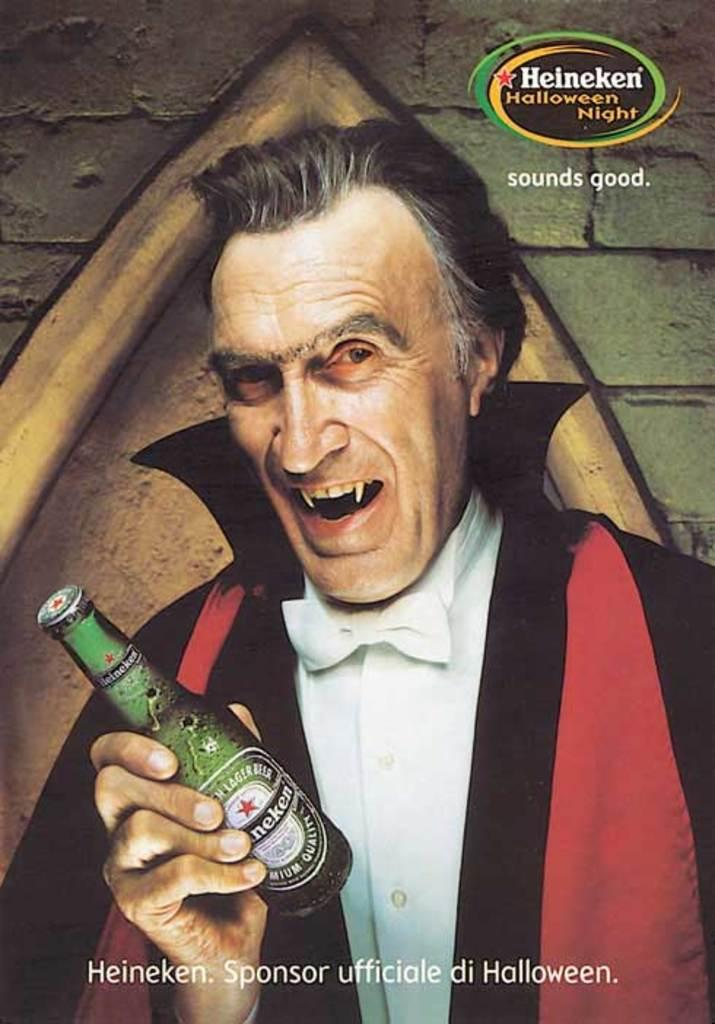Who is present in the image? There is a man in the image. What is the man holding in his hand? The man is holding a bottle in his hand. What is the man's facial expression? The man is smiling. What can be seen in the background of the image? There is a wall in the background of the image. What is on the wall in the background? There is a poster on the wall. What type of curtain can be seen hanging from the ceiling in the image? There is no curtain present in the image; it features a man holding a bottle and a poster on the wall. How many stars are visible in the image? There are no stars visible in the image. 